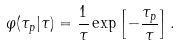<formula> <loc_0><loc_0><loc_500><loc_500>\varphi ( \tau _ { p } | \tau ) = \frac { 1 } { \tau } \exp \left [ - \frac { \tau _ { p } } { \tau } \right ] .</formula> 